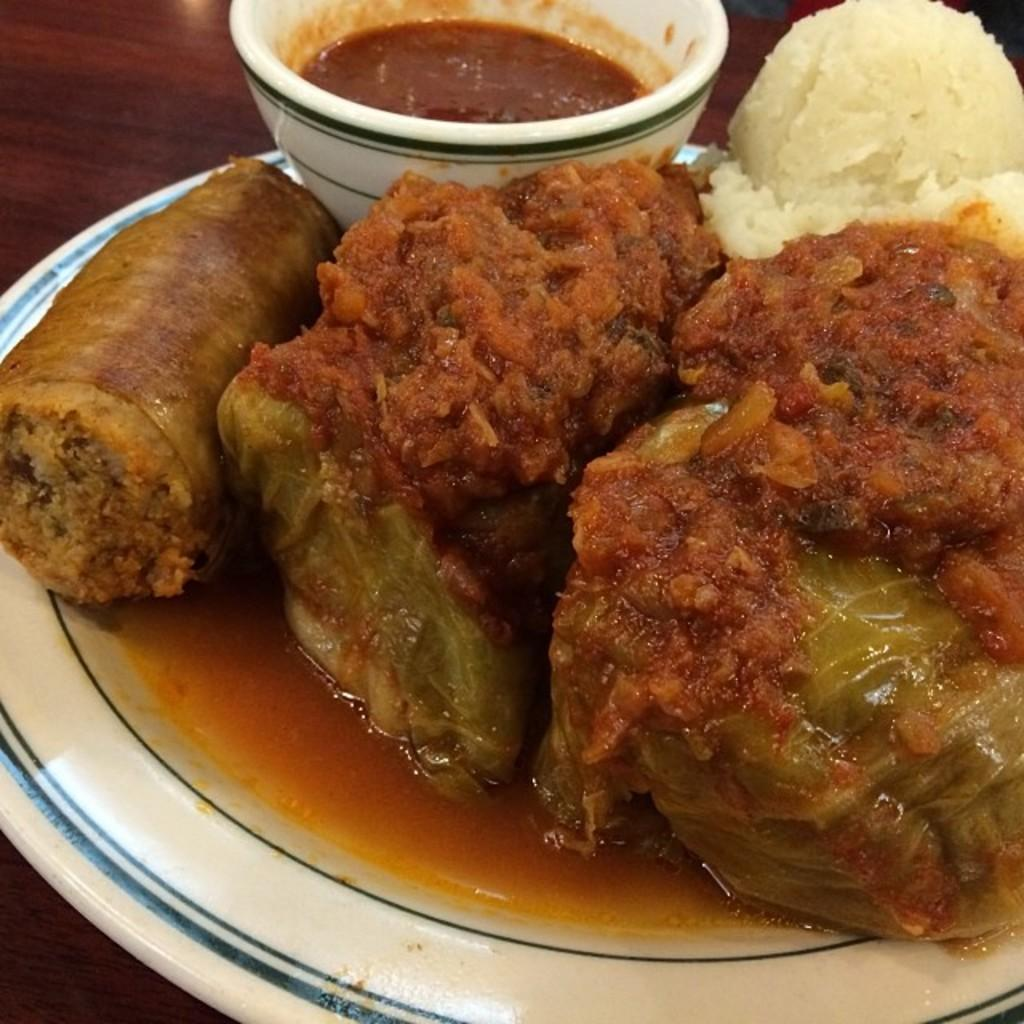What is present on the wooden platform in the image? There is a plate, food, and a bowl on the wooden platform in the image. What type of food can be seen on the plate? The specific type of food is not mentioned, but there is food visible on the plate. What is the bowl used for in the image? The purpose of the bowl is not specified, but it is present in the image. How much money is on the wooden platform in the image? There is no mention of money in the image; it only features a plate, food, and a bowl on a wooden platform. 